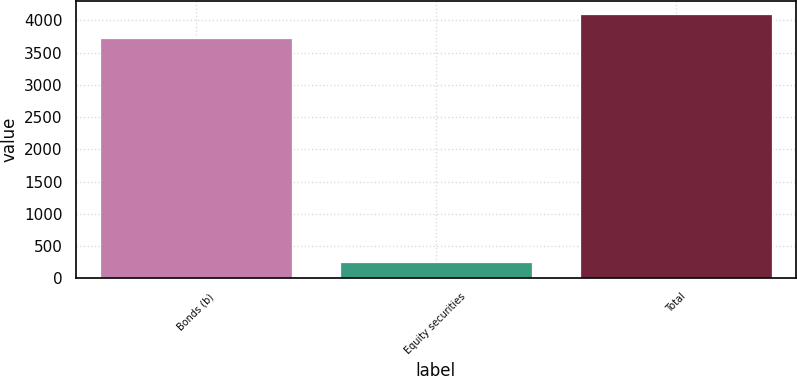Convert chart. <chart><loc_0><loc_0><loc_500><loc_500><bar_chart><fcel>Bonds (b)<fcel>Equity securities<fcel>Total<nl><fcel>3724<fcel>257<fcel>4096.4<nl></chart> 